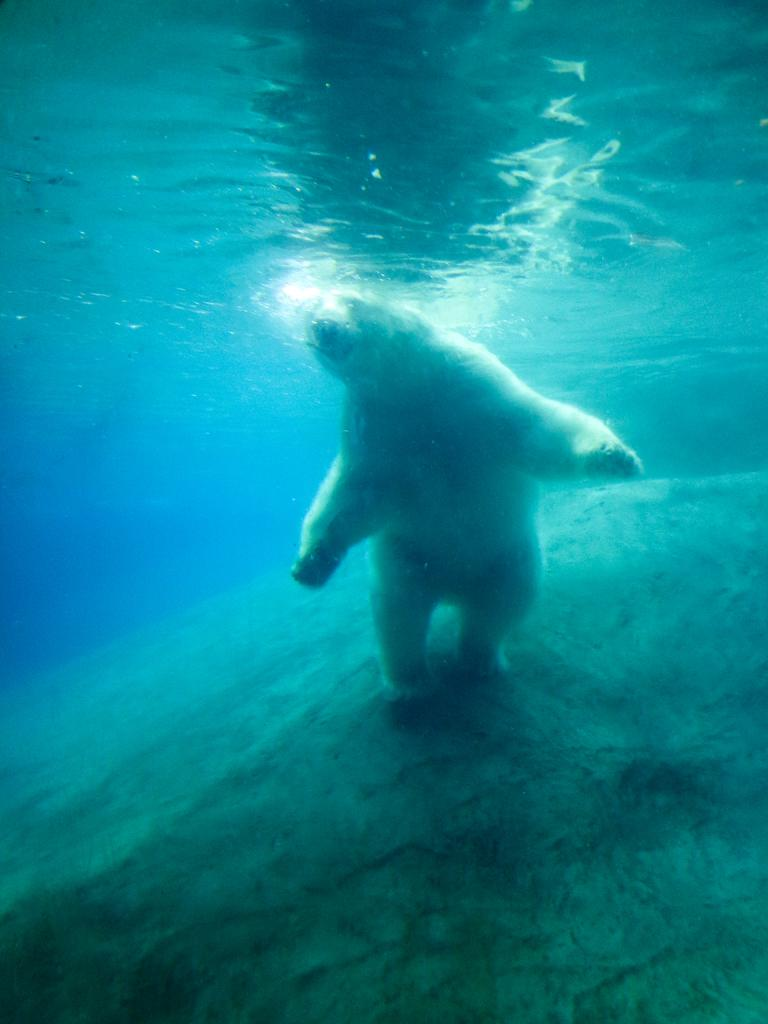What animal is in the image? There is a polar bear in the image. Where is the polar bear located? The polar bear is underwater. What is the polar bear standing on? The polar bear is on a big, ball-like surface. What is the texture of the brake in the image? There is no brake present in the image. Can you describe the behavior of the ant in the image? There is no ant present in the image. 